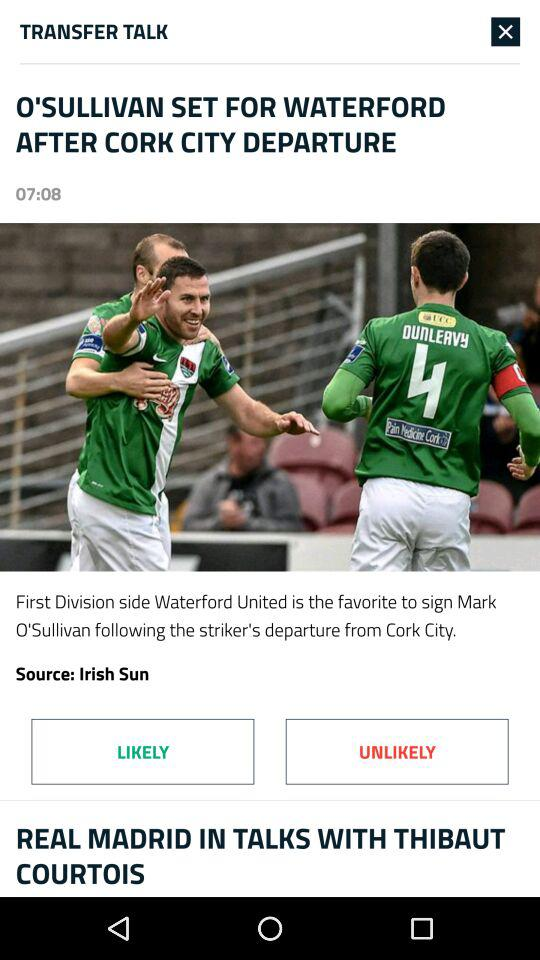What is the source of the article? The source of the article is "Irish Sun". 